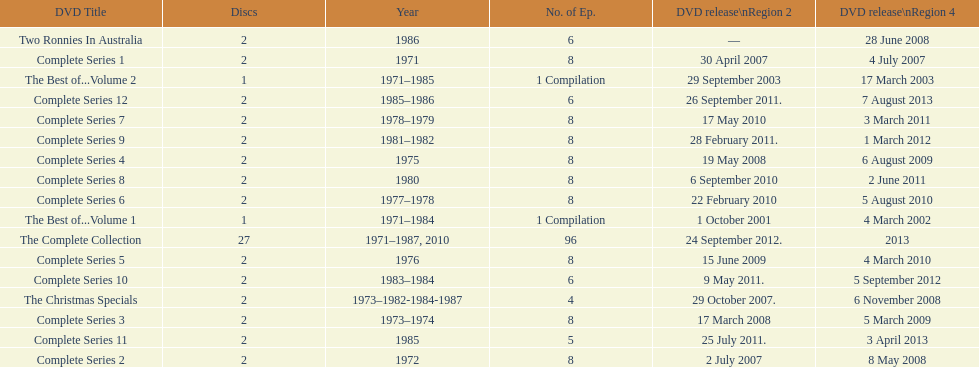Dvd shorter than 5 episodes The Christmas Specials. 